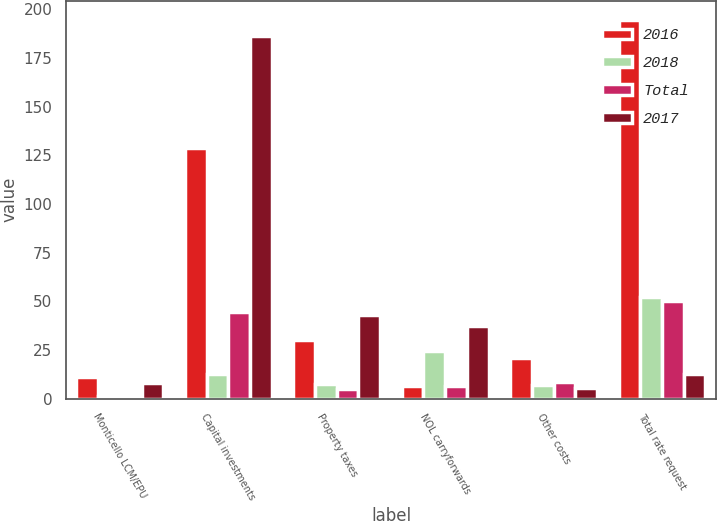Convert chart to OTSL. <chart><loc_0><loc_0><loc_500><loc_500><stacked_bar_chart><ecel><fcel>Monticello LCM/EPU<fcel>Capital investments<fcel>Property taxes<fcel>NOL carryforwards<fcel>Other costs<fcel>Total rate request<nl><fcel>2016<fcel>11.2<fcel>128.7<fcel>30.2<fcel>6.3<fcel>20.9<fcel>194.6<nl><fcel>2018<fcel>1.6<fcel>12.8<fcel>7.6<fcel>24.5<fcel>6.8<fcel>52.1<nl><fcel>Total<fcel>1.5<fcel>44.6<fcel>5.2<fcel>6.5<fcel>8.6<fcel>50.4<nl><fcel>2017<fcel>8.1<fcel>186.1<fcel>43<fcel>37.3<fcel>5.5<fcel>12.8<nl></chart> 